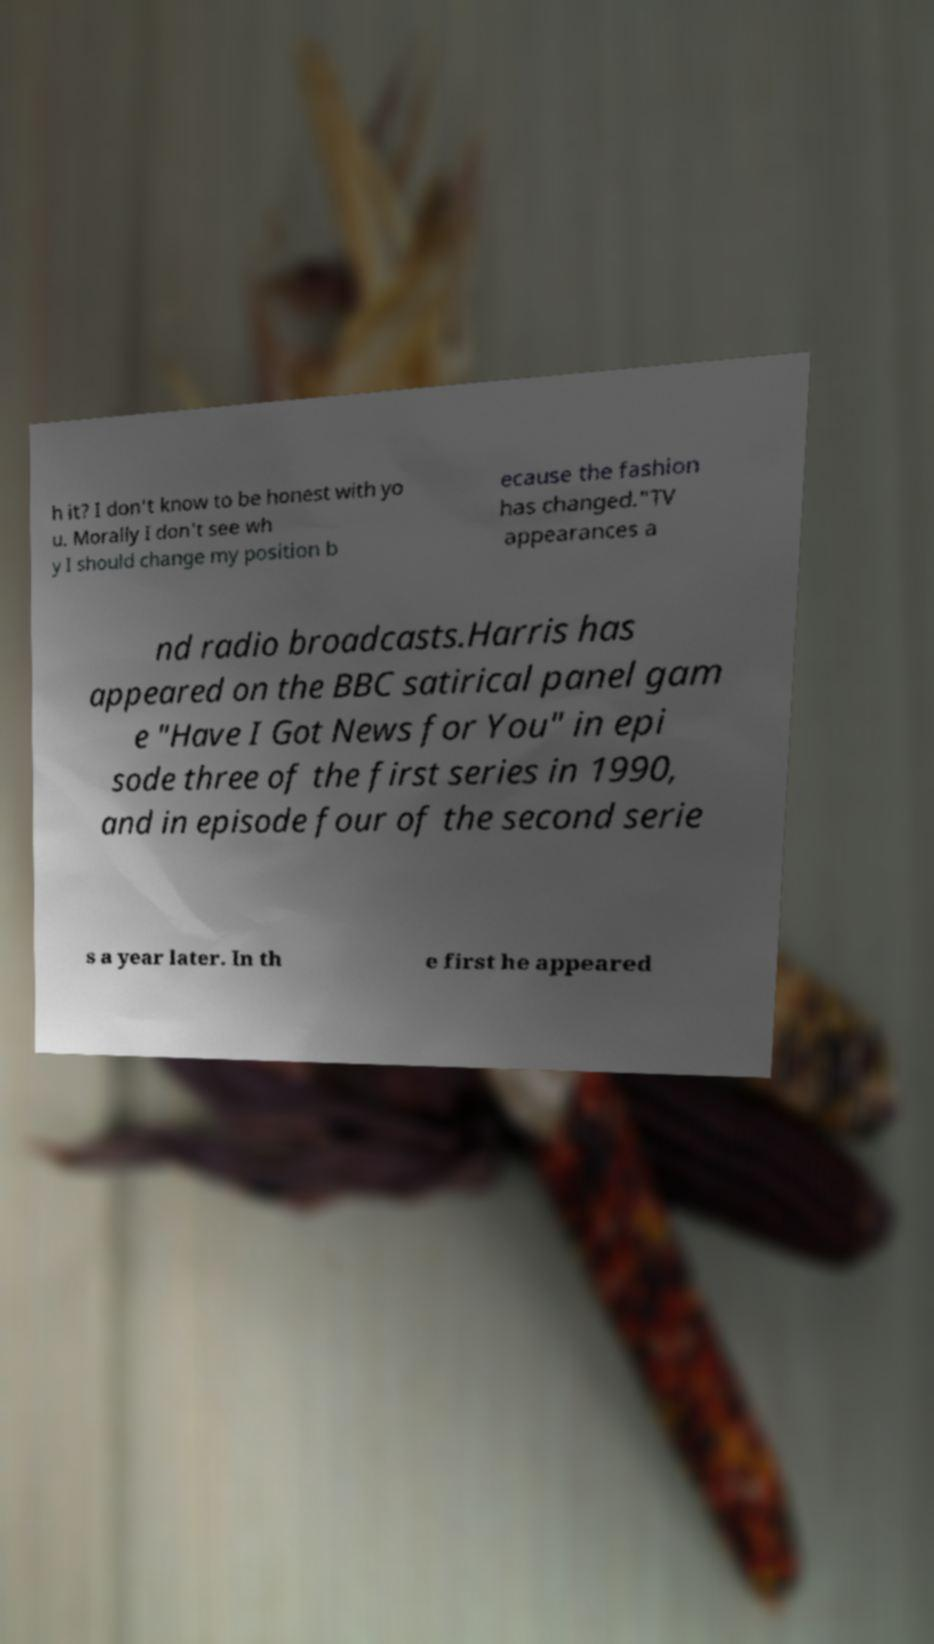Can you read and provide the text displayed in the image?This photo seems to have some interesting text. Can you extract and type it out for me? h it? I don't know to be honest with yo u. Morally I don't see wh y I should change my position b ecause the fashion has changed."TV appearances a nd radio broadcasts.Harris has appeared on the BBC satirical panel gam e "Have I Got News for You" in epi sode three of the first series in 1990, and in episode four of the second serie s a year later. In th e first he appeared 